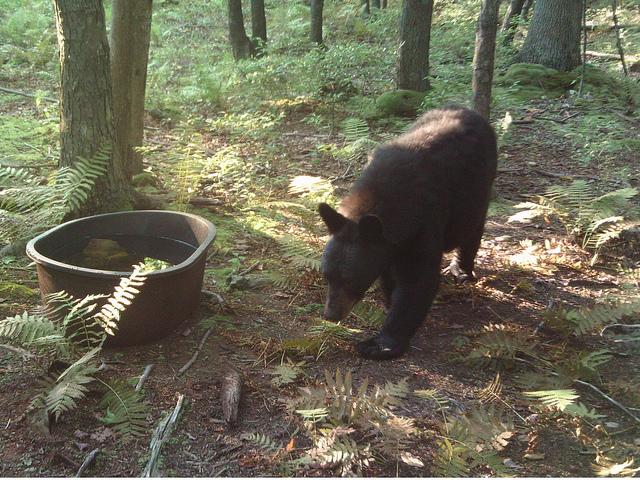How much does the bear weigh?
Be succinct. 200 pounds. What is the bear looking at?
Short answer required. Ground. What is this bear doing?
Give a very brief answer. Walking. 